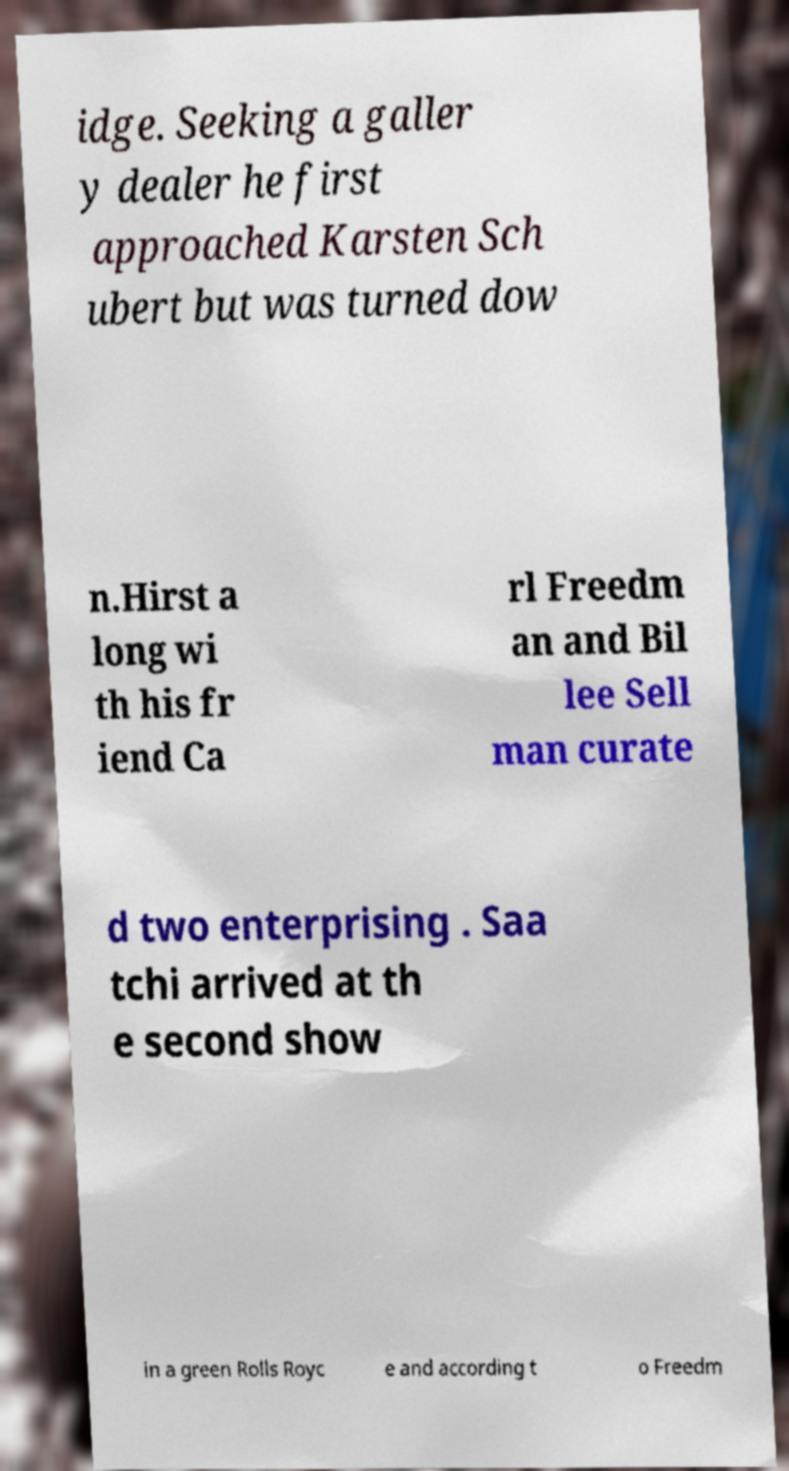Could you extract and type out the text from this image? idge. Seeking a galler y dealer he first approached Karsten Sch ubert but was turned dow n.Hirst a long wi th his fr iend Ca rl Freedm an and Bil lee Sell man curate d two enterprising . Saa tchi arrived at th e second show in a green Rolls Royc e and according t o Freedm 